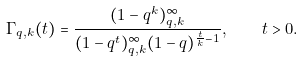Convert formula to latex. <formula><loc_0><loc_0><loc_500><loc_500>\Gamma _ { q , k } ( t ) = \frac { ( 1 - q ^ { k } ) _ { q , k } ^ { \infty } } { ( 1 - q ^ { t } ) _ { q , k } ^ { \infty } ( 1 - q ) ^ { \frac { t } { k } - 1 } } , \quad t > 0 .</formula> 